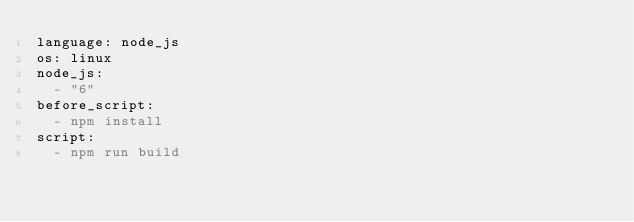<code> <loc_0><loc_0><loc_500><loc_500><_YAML_>language: node_js
os: linux
node_js:
  - "6"
before_script:
  - npm install
script:
  - npm run build
</code> 